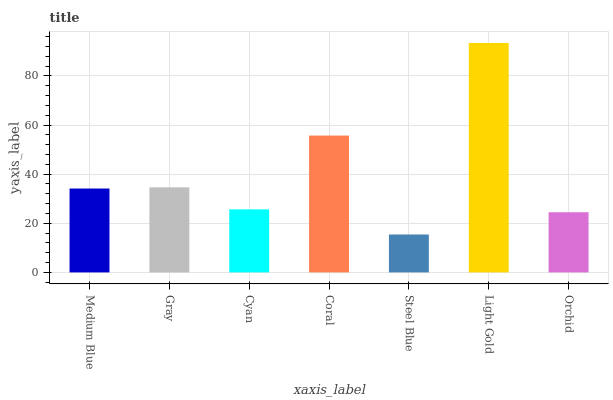Is Steel Blue the minimum?
Answer yes or no. Yes. Is Light Gold the maximum?
Answer yes or no. Yes. Is Gray the minimum?
Answer yes or no. No. Is Gray the maximum?
Answer yes or no. No. Is Gray greater than Medium Blue?
Answer yes or no. Yes. Is Medium Blue less than Gray?
Answer yes or no. Yes. Is Medium Blue greater than Gray?
Answer yes or no. No. Is Gray less than Medium Blue?
Answer yes or no. No. Is Medium Blue the high median?
Answer yes or no. Yes. Is Medium Blue the low median?
Answer yes or no. Yes. Is Steel Blue the high median?
Answer yes or no. No. Is Cyan the low median?
Answer yes or no. No. 